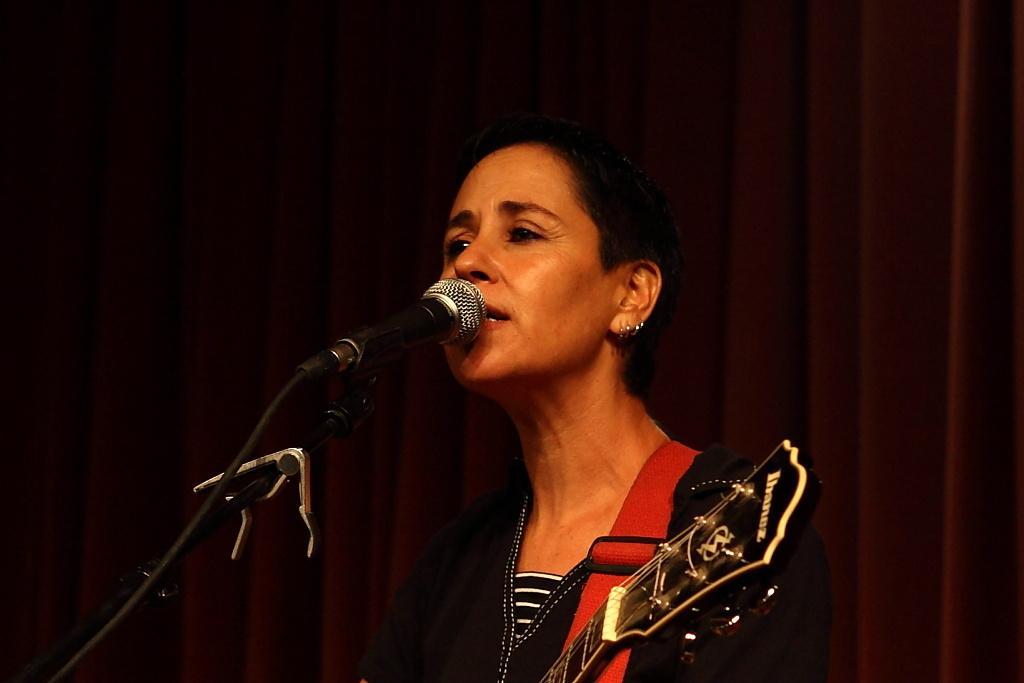In one or two sentences, can you explain what this image depicts? She is singing a song. She is holding a guitar. We can see in background black color curtain and microphone. 